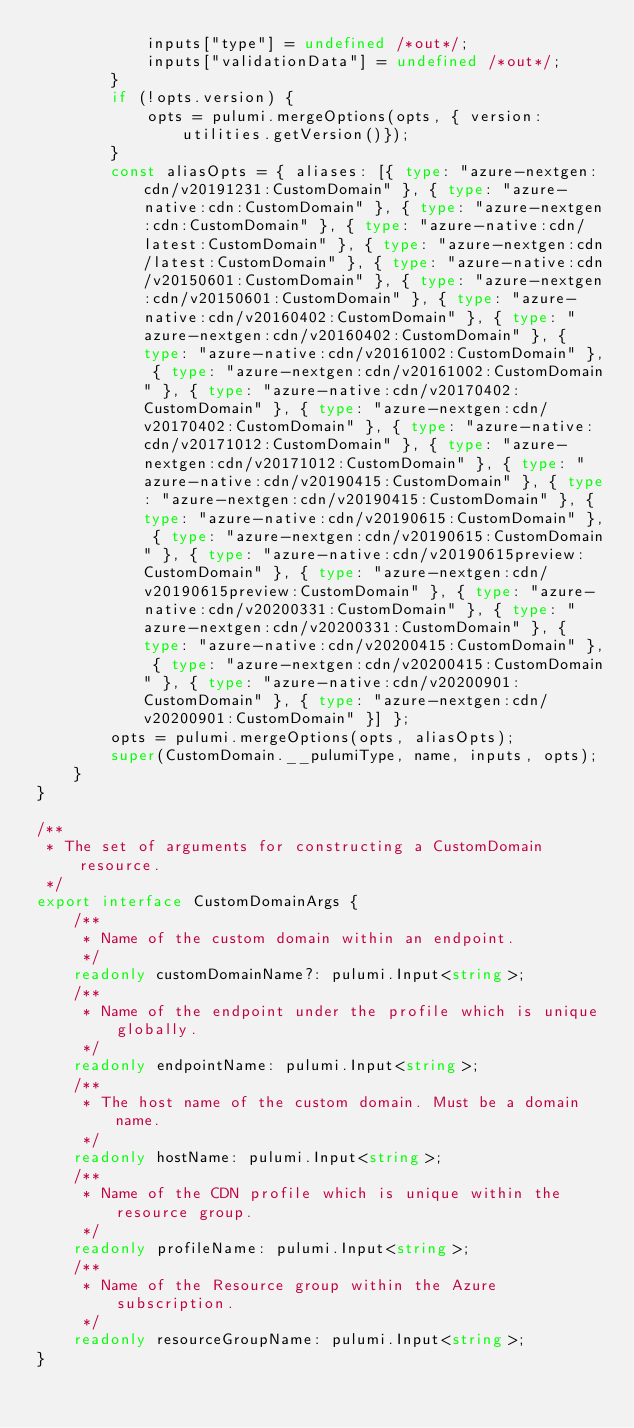Convert code to text. <code><loc_0><loc_0><loc_500><loc_500><_TypeScript_>            inputs["type"] = undefined /*out*/;
            inputs["validationData"] = undefined /*out*/;
        }
        if (!opts.version) {
            opts = pulumi.mergeOptions(opts, { version: utilities.getVersion()});
        }
        const aliasOpts = { aliases: [{ type: "azure-nextgen:cdn/v20191231:CustomDomain" }, { type: "azure-native:cdn:CustomDomain" }, { type: "azure-nextgen:cdn:CustomDomain" }, { type: "azure-native:cdn/latest:CustomDomain" }, { type: "azure-nextgen:cdn/latest:CustomDomain" }, { type: "azure-native:cdn/v20150601:CustomDomain" }, { type: "azure-nextgen:cdn/v20150601:CustomDomain" }, { type: "azure-native:cdn/v20160402:CustomDomain" }, { type: "azure-nextgen:cdn/v20160402:CustomDomain" }, { type: "azure-native:cdn/v20161002:CustomDomain" }, { type: "azure-nextgen:cdn/v20161002:CustomDomain" }, { type: "azure-native:cdn/v20170402:CustomDomain" }, { type: "azure-nextgen:cdn/v20170402:CustomDomain" }, { type: "azure-native:cdn/v20171012:CustomDomain" }, { type: "azure-nextgen:cdn/v20171012:CustomDomain" }, { type: "azure-native:cdn/v20190415:CustomDomain" }, { type: "azure-nextgen:cdn/v20190415:CustomDomain" }, { type: "azure-native:cdn/v20190615:CustomDomain" }, { type: "azure-nextgen:cdn/v20190615:CustomDomain" }, { type: "azure-native:cdn/v20190615preview:CustomDomain" }, { type: "azure-nextgen:cdn/v20190615preview:CustomDomain" }, { type: "azure-native:cdn/v20200331:CustomDomain" }, { type: "azure-nextgen:cdn/v20200331:CustomDomain" }, { type: "azure-native:cdn/v20200415:CustomDomain" }, { type: "azure-nextgen:cdn/v20200415:CustomDomain" }, { type: "azure-native:cdn/v20200901:CustomDomain" }, { type: "azure-nextgen:cdn/v20200901:CustomDomain" }] };
        opts = pulumi.mergeOptions(opts, aliasOpts);
        super(CustomDomain.__pulumiType, name, inputs, opts);
    }
}

/**
 * The set of arguments for constructing a CustomDomain resource.
 */
export interface CustomDomainArgs {
    /**
     * Name of the custom domain within an endpoint.
     */
    readonly customDomainName?: pulumi.Input<string>;
    /**
     * Name of the endpoint under the profile which is unique globally.
     */
    readonly endpointName: pulumi.Input<string>;
    /**
     * The host name of the custom domain. Must be a domain name.
     */
    readonly hostName: pulumi.Input<string>;
    /**
     * Name of the CDN profile which is unique within the resource group.
     */
    readonly profileName: pulumi.Input<string>;
    /**
     * Name of the Resource group within the Azure subscription.
     */
    readonly resourceGroupName: pulumi.Input<string>;
}
</code> 